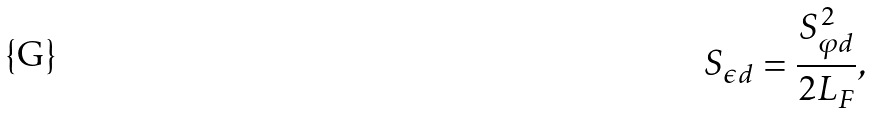<formula> <loc_0><loc_0><loc_500><loc_500>S _ { \epsilon d } = \frac { S ^ { 2 } _ { \varphi d } } { 2 L _ { F } } ,</formula> 